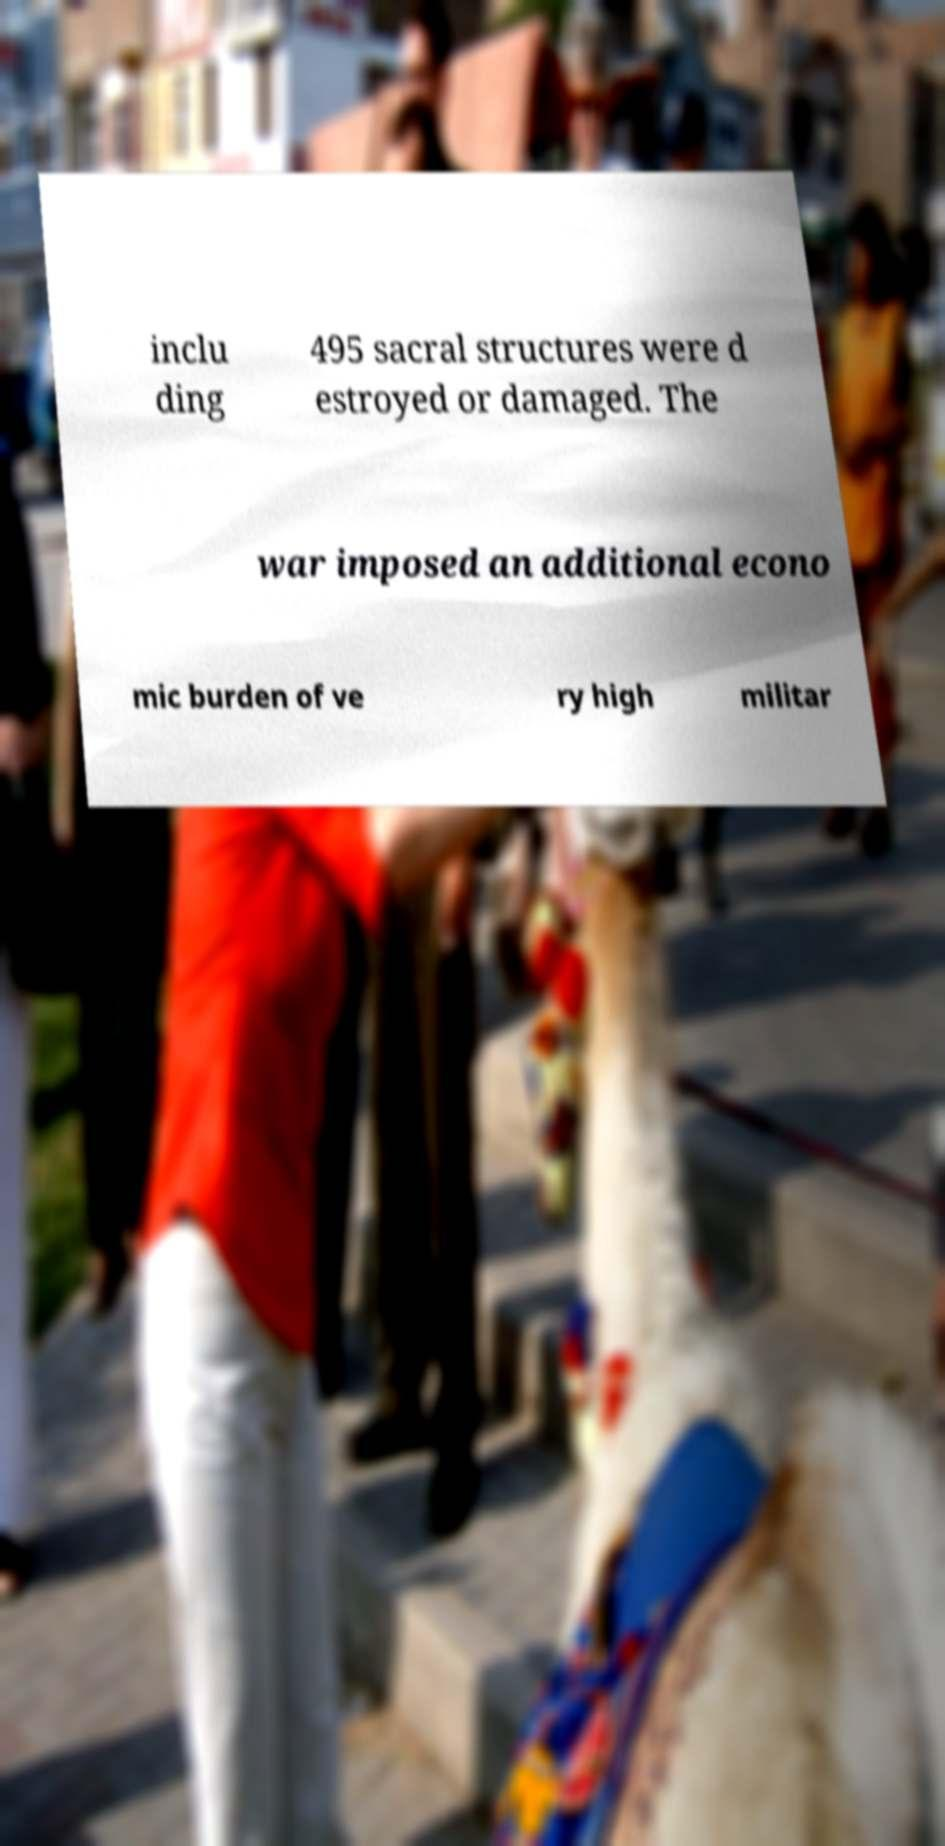What messages or text are displayed in this image? I need them in a readable, typed format. inclu ding 495 sacral structures were d estroyed or damaged. The war imposed an additional econo mic burden of ve ry high militar 